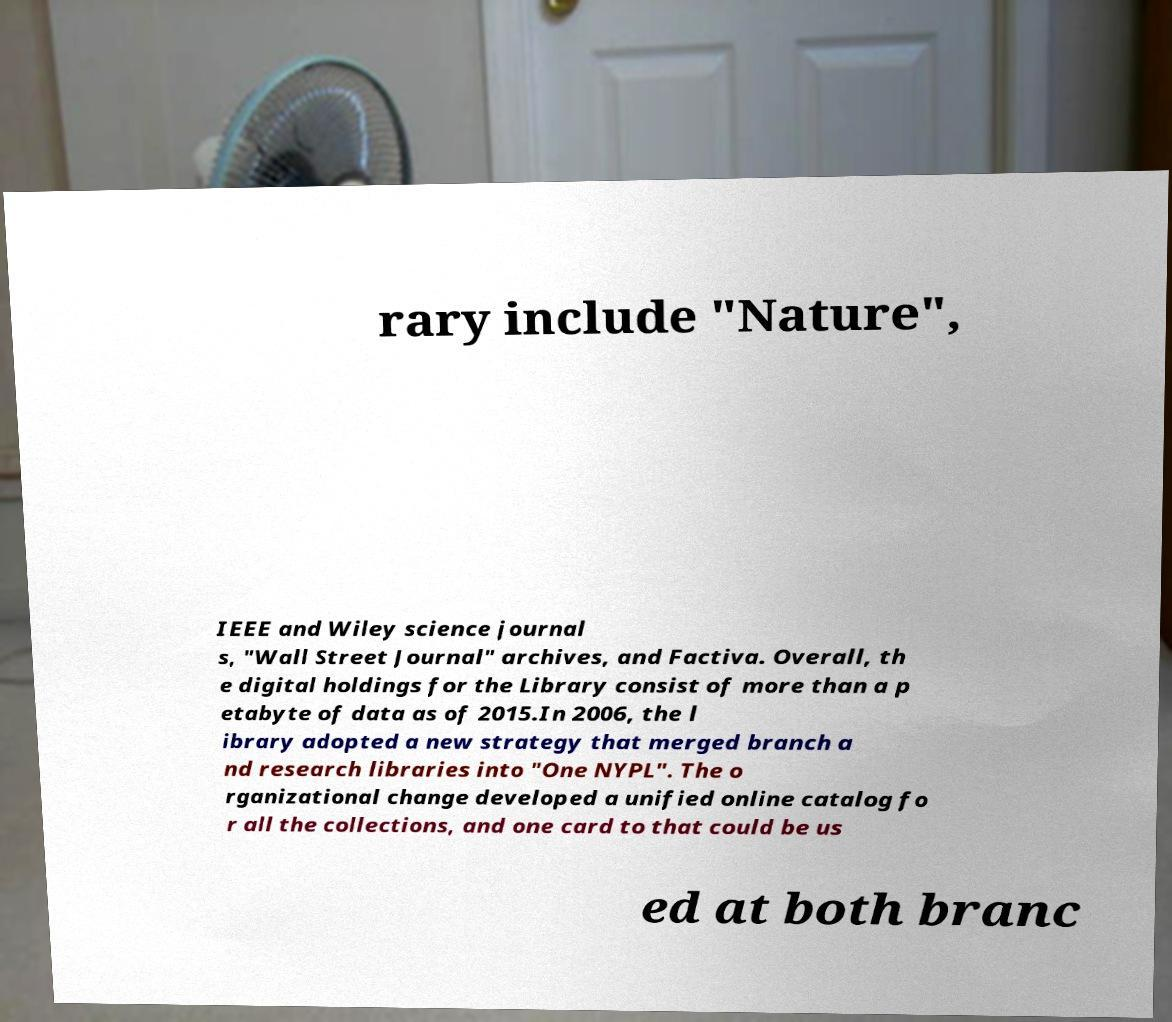For documentation purposes, I need the text within this image transcribed. Could you provide that? rary include "Nature", IEEE and Wiley science journal s, "Wall Street Journal" archives, and Factiva. Overall, th e digital holdings for the Library consist of more than a p etabyte of data as of 2015.In 2006, the l ibrary adopted a new strategy that merged branch a nd research libraries into "One NYPL". The o rganizational change developed a unified online catalog fo r all the collections, and one card to that could be us ed at both branc 